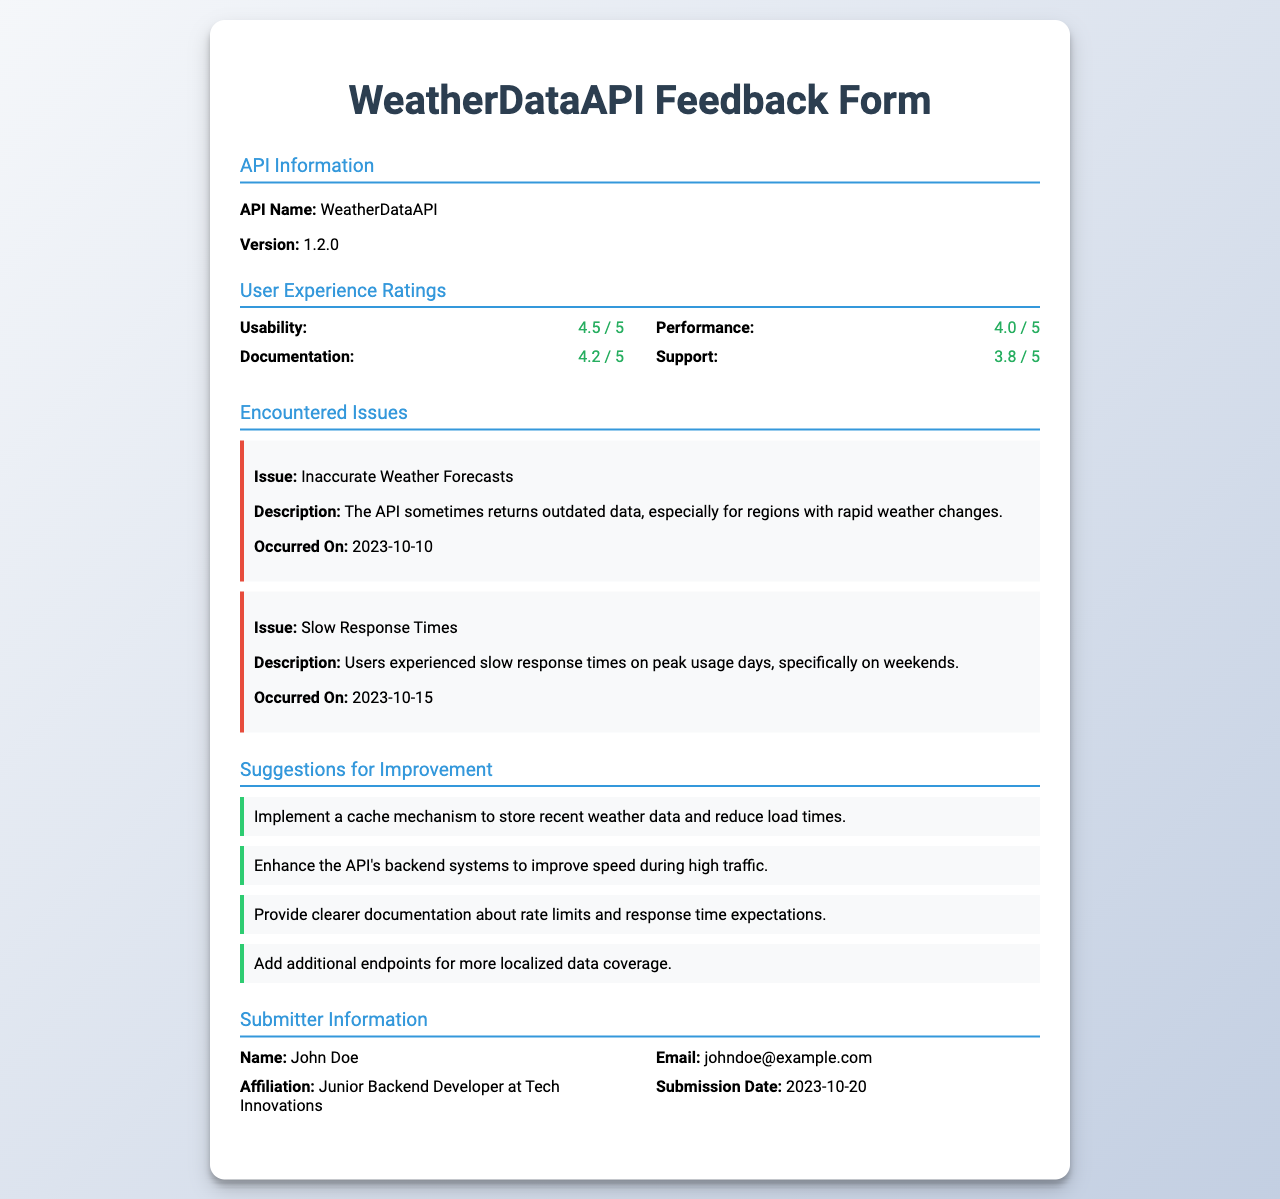What is the API name? The API name is listed in the API Information section of the document.
Answer: WeatherDataAPI What is the current version of the API? The version is specified in the API Information section.
Answer: 1.2.0 What was the usability rating given by users? The usability rating is found in the User Experience Ratings section.
Answer: 4.5 / 5 What issue occurred on October 10, 2023? This date is associated with an issue described in the Encountered Issues section.
Answer: Inaccurate Weather Forecasts What suggestion was made to improve response times? Suggestions are listed in the Suggestions for Improvement section.
Answer: Enhance the API's backend systems to improve speed during high traffic How many issues are documented in total? The number of documented issues can be counted from the Encountered Issues section.
Answer: 2 Who submitted the feedback? The submitter's name is provided in the Submitter Information section.
Answer: John Doe What is the submitter's email address? The email address can be found in the Submitter Information section.
Answer: johndoe@example.com What date was the feedback submitted? The submission date is stated in the Submitter Information section.
Answer: 2023-10-20 